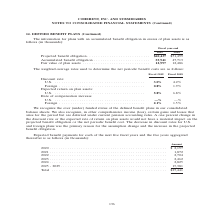According to Coherent's financial document, What was the Projected benefit obligation in 2019? According to the financial document, $60,437 (in thousands). The relevant text states: "Projected benefit obligation . $60,437 $51,499 Accumulated benefit obligation . 55,941 47,713 Fair value of plan assets . 12,997 12,486..." Also, What was the  Accumulated benefit obligation  in 2018? According to the financial document, 47,713 (in thousands). The relevant text states: "7 $51,499 Accumulated benefit obligation . 55,941 47,713 Fair value of plan assets . 12,997 12,486..." Also, In which years was information on defined benefit plans provided? The document shows two values: 2019 and 2018. From the document: "Fiscal year-end 2019 2018 Fiscal year-end 2019 2018..." Additionally, In which year was the Fair value of plan assets larger? According to the financial document, 2019. The relevant text states: "Fiscal year-end 2019 2018..." Also, can you calculate: What was the change in Fair value of plan assets from 2018 to 2019? Based on the calculation: 12,997-12,486, the result is 511 (in thousands). This is based on the information: "55,941 47,713 Fair value of plan assets . 12,997 12,486 ation . 55,941 47,713 Fair value of plan assets . 12,997 12,486..." The key data points involved are: 12,486, 12,997. Also, can you calculate: What was the percentage change in Fair value of plan assets from 2018 to 2019? To answer this question, I need to perform calculations using the financial data. The calculation is: (12,997-12,486)/12,486, which equals 4.09 (percentage). This is based on the information: "55,941 47,713 Fair value of plan assets . 12,997 12,486 ation . 55,941 47,713 Fair value of plan assets . 12,997 12,486..." The key data points involved are: 12,486, 12,997. 